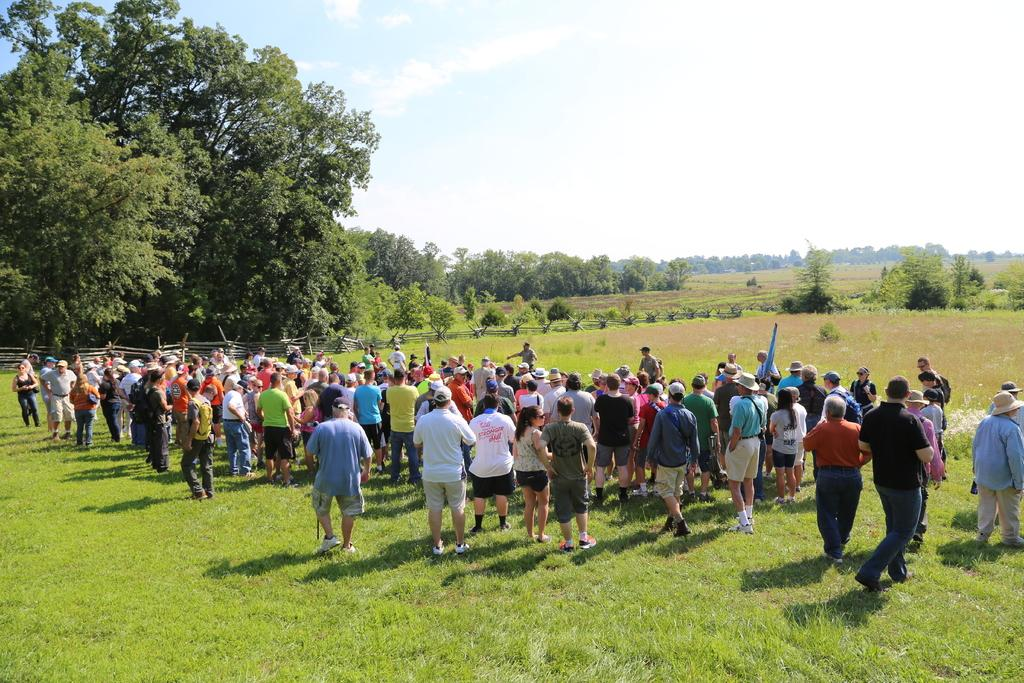What is the main feature of the image? There are many people standing on the grass. What type of vegetation can be seen in the image? There are many trees in the image. What is the purpose of the fence in the image? The fence is likely used to separate or enclose an area. What is visible at the top of the image? The sky is visible at the top of the image. What type of brush is being used to paint the advertisement on the jar in the image? There is no brush, advertisement, or jar present in the image. 